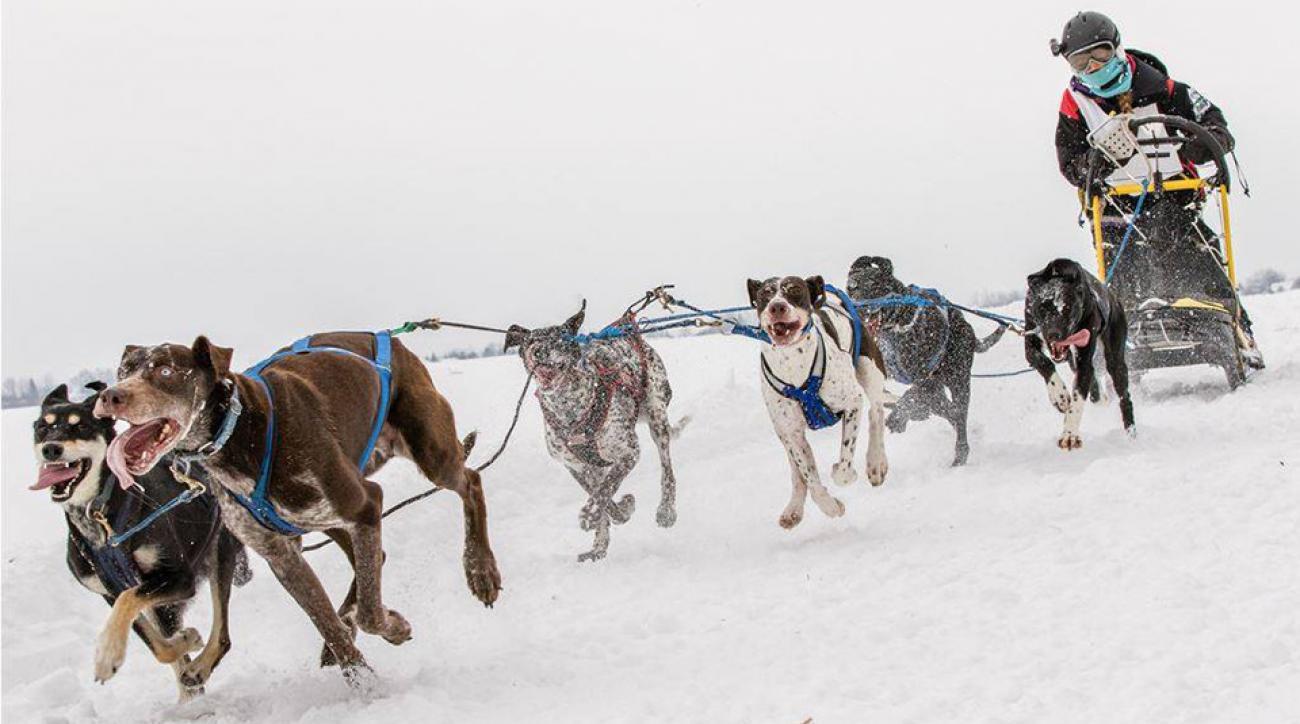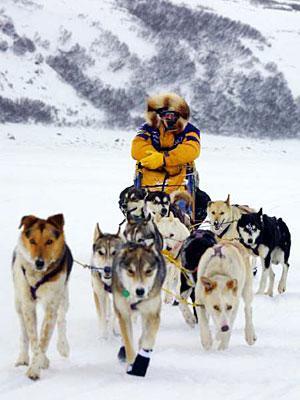The first image is the image on the left, the second image is the image on the right. Analyze the images presented: Is the assertion "Each image shows a sled driver behind a team of dogs moving forward over snow, and a lead dog wears black booties in the team on the right." valid? Answer yes or no. Yes. 